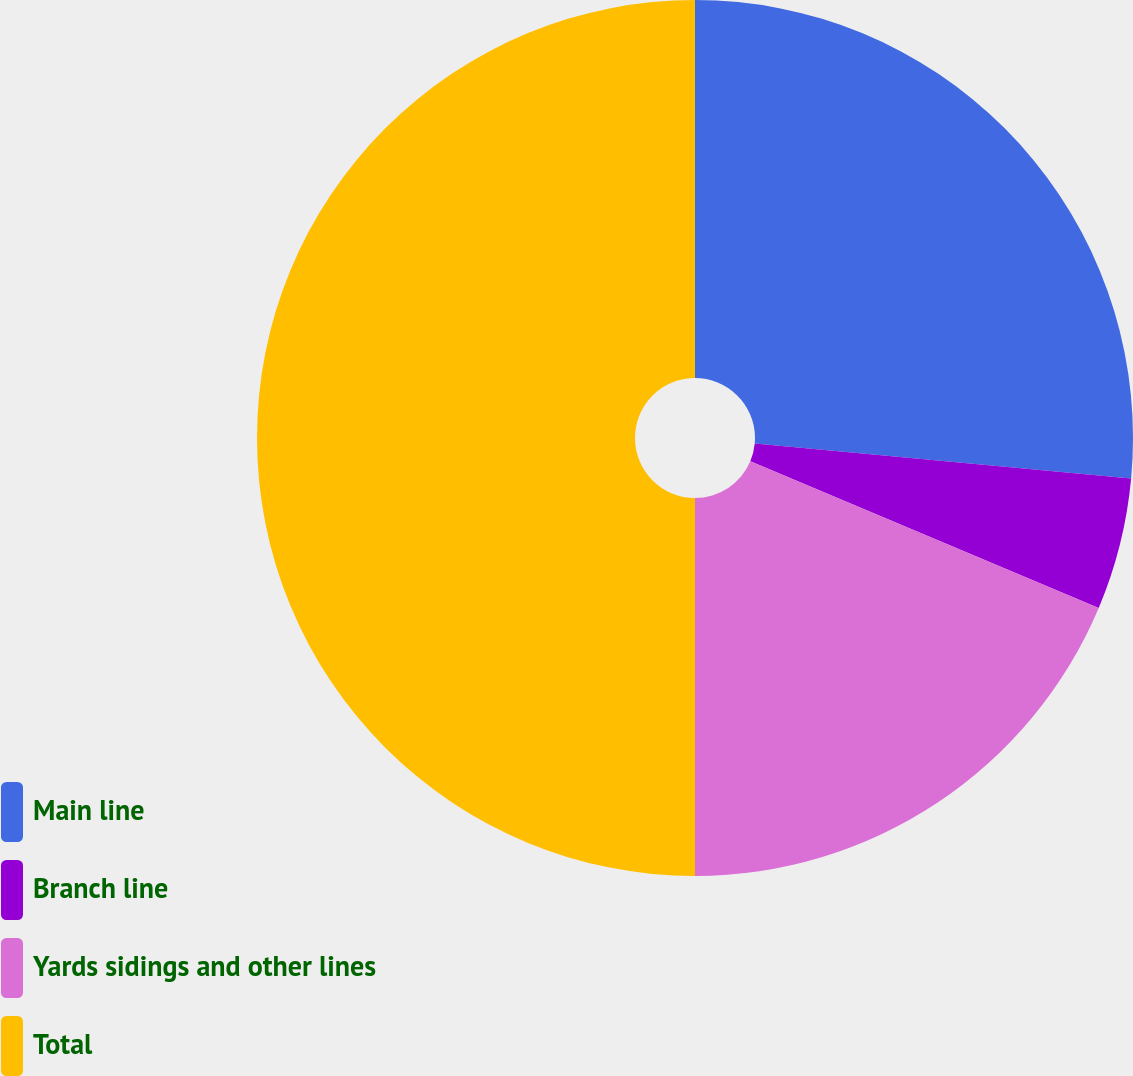Convert chart to OTSL. <chart><loc_0><loc_0><loc_500><loc_500><pie_chart><fcel>Main line<fcel>Branch line<fcel>Yards sidings and other lines<fcel>Total<nl><fcel>26.47%<fcel>4.87%<fcel>18.66%<fcel>50.0%<nl></chart> 